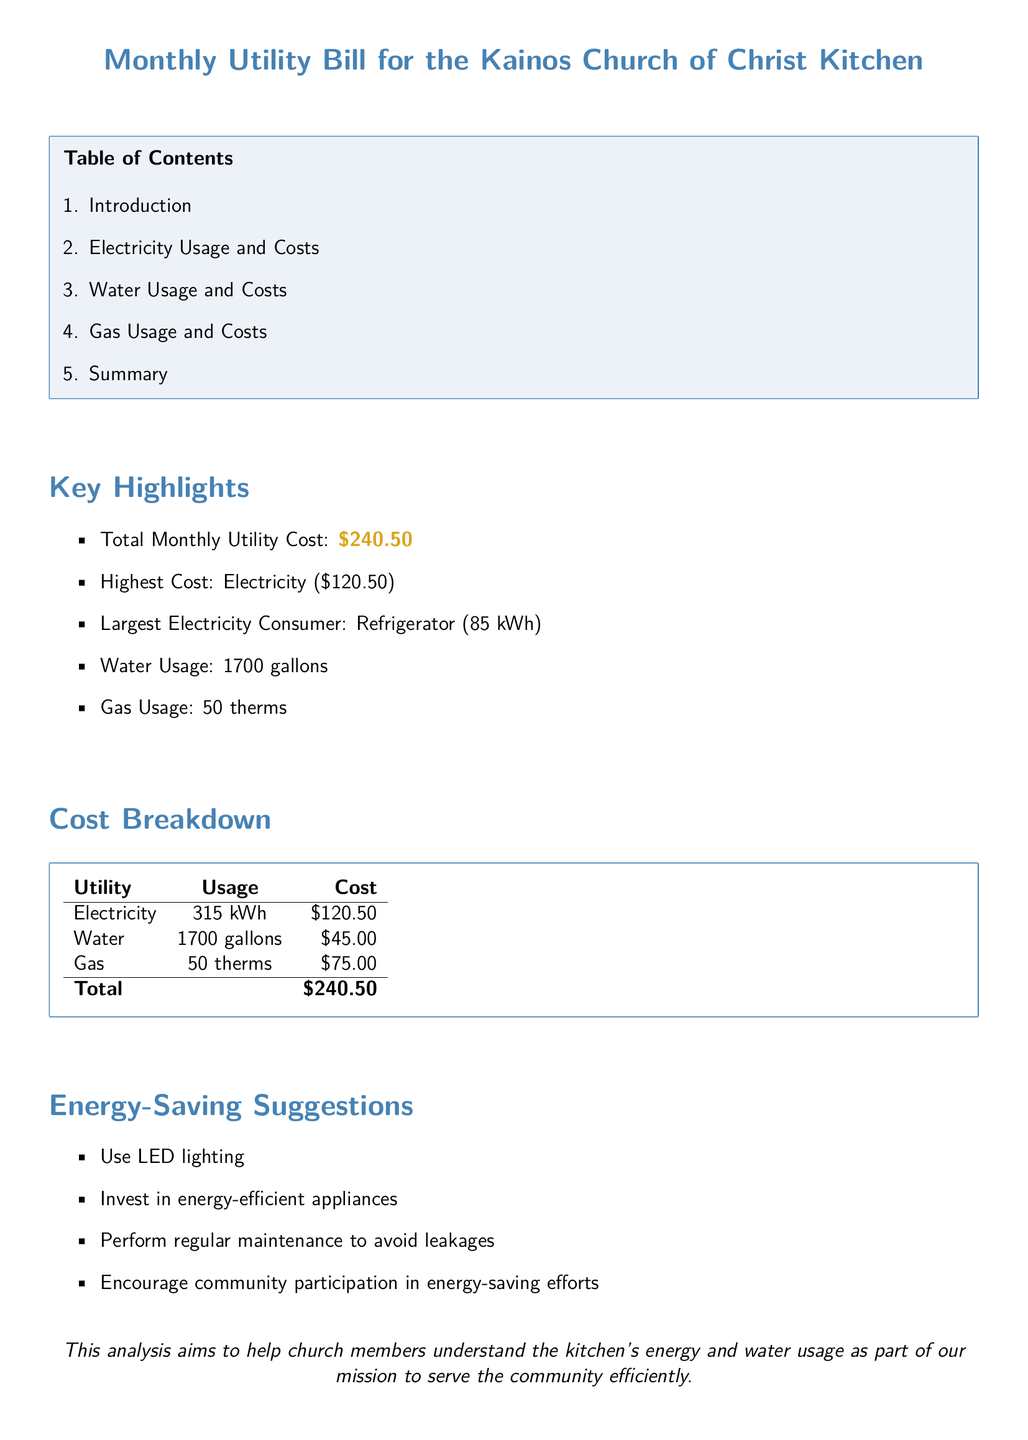What is the total monthly utility cost? The total monthly utility cost is found in the Key Highlights section, which states \$240.50.
Answer: \$240.50 What is the highest utility cost? The highest utility cost is mentioned in the Key Highlights section, which identifies Electricity at \$120.50.
Answer: Electricity (\$120.50) How much water was used? The water usage is detailed in the Key Highlights section, which states 1700 gallons.
Answer: 1700 gallons What is the usage of electricity? The electricity usage is provided in the Cost Breakdown table, which lists 315 kWh.
Answer: 315 kWh Which appliance is the largest electricity consumer? The Key Highlights section mentions the refrigerator as the largest electricity consumer, using 85 kWh.
Answer: Refrigerator What are the suggestions for saving energy? The Energy-Saving Suggestions section outlines several methods; one example is using LED lighting.
Answer: Use LED lighting How many therms of gas were used? The gas usage is detailed in the Cost Breakdown table, which states 50 therms.
Answer: 50 therms What is the cost of water? The Cost Breakdown table lists the cost of water as \$45.00.
Answer: \$45.00 How many gallons of water correspond to the total monthly utility cost? The total cost is a sum of the individual utility costs, which correlates to the water usage of 1700 gallons for \$45.00.
Answer: 1700 gallons 